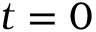<formula> <loc_0><loc_0><loc_500><loc_500>t = 0</formula> 